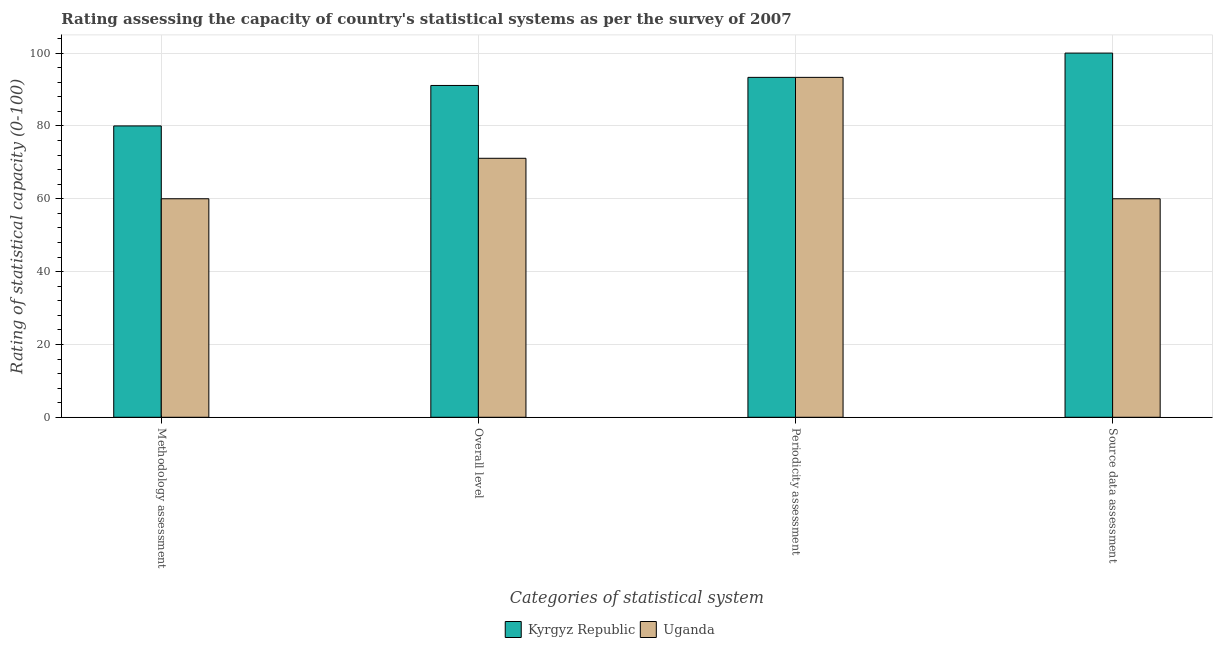How many different coloured bars are there?
Provide a succinct answer. 2. Are the number of bars per tick equal to the number of legend labels?
Give a very brief answer. Yes. What is the label of the 4th group of bars from the left?
Offer a very short reply. Source data assessment. Across all countries, what is the maximum periodicity assessment rating?
Your answer should be very brief. 93.33. Across all countries, what is the minimum source data assessment rating?
Your response must be concise. 60. In which country was the periodicity assessment rating maximum?
Give a very brief answer. Kyrgyz Republic. In which country was the overall level rating minimum?
Make the answer very short. Uganda. What is the total methodology assessment rating in the graph?
Provide a short and direct response. 140. What is the difference between the source data assessment rating in Uganda and that in Kyrgyz Republic?
Provide a short and direct response. -40. What is the difference between the methodology assessment rating in Kyrgyz Republic and the overall level rating in Uganda?
Keep it short and to the point. 8.89. What is the average overall level rating per country?
Provide a succinct answer. 81.11. What is the difference between the periodicity assessment rating and methodology assessment rating in Uganda?
Give a very brief answer. 33.33. In how many countries, is the source data assessment rating greater than 36 ?
Ensure brevity in your answer.  2. What is the ratio of the overall level rating in Uganda to that in Kyrgyz Republic?
Give a very brief answer. 0.78. What is the difference between the highest and the second highest periodicity assessment rating?
Keep it short and to the point. 0. In how many countries, is the source data assessment rating greater than the average source data assessment rating taken over all countries?
Provide a succinct answer. 1. Is it the case that in every country, the sum of the source data assessment rating and methodology assessment rating is greater than the sum of periodicity assessment rating and overall level rating?
Your response must be concise. No. What does the 2nd bar from the left in Source data assessment represents?
Keep it short and to the point. Uganda. What does the 1st bar from the right in Source data assessment represents?
Provide a short and direct response. Uganda. How many bars are there?
Ensure brevity in your answer.  8. How many countries are there in the graph?
Provide a succinct answer. 2. What is the difference between two consecutive major ticks on the Y-axis?
Offer a very short reply. 20. Does the graph contain any zero values?
Provide a succinct answer. No. Where does the legend appear in the graph?
Make the answer very short. Bottom center. How are the legend labels stacked?
Your answer should be compact. Horizontal. What is the title of the graph?
Your response must be concise. Rating assessing the capacity of country's statistical systems as per the survey of 2007 . What is the label or title of the X-axis?
Your response must be concise. Categories of statistical system. What is the label or title of the Y-axis?
Keep it short and to the point. Rating of statistical capacity (0-100). What is the Rating of statistical capacity (0-100) of Kyrgyz Republic in Methodology assessment?
Your response must be concise. 80. What is the Rating of statistical capacity (0-100) of Uganda in Methodology assessment?
Your answer should be very brief. 60. What is the Rating of statistical capacity (0-100) of Kyrgyz Republic in Overall level?
Provide a short and direct response. 91.11. What is the Rating of statistical capacity (0-100) in Uganda in Overall level?
Your answer should be very brief. 71.11. What is the Rating of statistical capacity (0-100) in Kyrgyz Republic in Periodicity assessment?
Give a very brief answer. 93.33. What is the Rating of statistical capacity (0-100) of Uganda in Periodicity assessment?
Your answer should be very brief. 93.33. What is the Rating of statistical capacity (0-100) in Kyrgyz Republic in Source data assessment?
Provide a succinct answer. 100. What is the Rating of statistical capacity (0-100) in Uganda in Source data assessment?
Make the answer very short. 60. Across all Categories of statistical system, what is the maximum Rating of statistical capacity (0-100) of Uganda?
Your answer should be compact. 93.33. What is the total Rating of statistical capacity (0-100) of Kyrgyz Republic in the graph?
Offer a very short reply. 364.44. What is the total Rating of statistical capacity (0-100) of Uganda in the graph?
Keep it short and to the point. 284.44. What is the difference between the Rating of statistical capacity (0-100) in Kyrgyz Republic in Methodology assessment and that in Overall level?
Your answer should be very brief. -11.11. What is the difference between the Rating of statistical capacity (0-100) of Uganda in Methodology assessment and that in Overall level?
Your answer should be very brief. -11.11. What is the difference between the Rating of statistical capacity (0-100) of Kyrgyz Republic in Methodology assessment and that in Periodicity assessment?
Provide a succinct answer. -13.33. What is the difference between the Rating of statistical capacity (0-100) of Uganda in Methodology assessment and that in Periodicity assessment?
Make the answer very short. -33.33. What is the difference between the Rating of statistical capacity (0-100) in Kyrgyz Republic in Overall level and that in Periodicity assessment?
Offer a terse response. -2.22. What is the difference between the Rating of statistical capacity (0-100) of Uganda in Overall level and that in Periodicity assessment?
Offer a very short reply. -22.22. What is the difference between the Rating of statistical capacity (0-100) in Kyrgyz Republic in Overall level and that in Source data assessment?
Ensure brevity in your answer.  -8.89. What is the difference between the Rating of statistical capacity (0-100) in Uganda in Overall level and that in Source data assessment?
Give a very brief answer. 11.11. What is the difference between the Rating of statistical capacity (0-100) in Kyrgyz Republic in Periodicity assessment and that in Source data assessment?
Offer a terse response. -6.67. What is the difference between the Rating of statistical capacity (0-100) of Uganda in Periodicity assessment and that in Source data assessment?
Keep it short and to the point. 33.33. What is the difference between the Rating of statistical capacity (0-100) in Kyrgyz Republic in Methodology assessment and the Rating of statistical capacity (0-100) in Uganda in Overall level?
Make the answer very short. 8.89. What is the difference between the Rating of statistical capacity (0-100) in Kyrgyz Republic in Methodology assessment and the Rating of statistical capacity (0-100) in Uganda in Periodicity assessment?
Make the answer very short. -13.33. What is the difference between the Rating of statistical capacity (0-100) of Kyrgyz Republic in Overall level and the Rating of statistical capacity (0-100) of Uganda in Periodicity assessment?
Your response must be concise. -2.22. What is the difference between the Rating of statistical capacity (0-100) of Kyrgyz Republic in Overall level and the Rating of statistical capacity (0-100) of Uganda in Source data assessment?
Offer a very short reply. 31.11. What is the difference between the Rating of statistical capacity (0-100) in Kyrgyz Republic in Periodicity assessment and the Rating of statistical capacity (0-100) in Uganda in Source data assessment?
Offer a terse response. 33.33. What is the average Rating of statistical capacity (0-100) in Kyrgyz Republic per Categories of statistical system?
Your response must be concise. 91.11. What is the average Rating of statistical capacity (0-100) of Uganda per Categories of statistical system?
Make the answer very short. 71.11. What is the ratio of the Rating of statistical capacity (0-100) of Kyrgyz Republic in Methodology assessment to that in Overall level?
Make the answer very short. 0.88. What is the ratio of the Rating of statistical capacity (0-100) in Uganda in Methodology assessment to that in Overall level?
Your response must be concise. 0.84. What is the ratio of the Rating of statistical capacity (0-100) in Kyrgyz Republic in Methodology assessment to that in Periodicity assessment?
Your response must be concise. 0.86. What is the ratio of the Rating of statistical capacity (0-100) in Uganda in Methodology assessment to that in Periodicity assessment?
Offer a terse response. 0.64. What is the ratio of the Rating of statistical capacity (0-100) of Kyrgyz Republic in Methodology assessment to that in Source data assessment?
Make the answer very short. 0.8. What is the ratio of the Rating of statistical capacity (0-100) of Kyrgyz Republic in Overall level to that in Periodicity assessment?
Keep it short and to the point. 0.98. What is the ratio of the Rating of statistical capacity (0-100) in Uganda in Overall level to that in Periodicity assessment?
Provide a succinct answer. 0.76. What is the ratio of the Rating of statistical capacity (0-100) in Kyrgyz Republic in Overall level to that in Source data assessment?
Your answer should be compact. 0.91. What is the ratio of the Rating of statistical capacity (0-100) in Uganda in Overall level to that in Source data assessment?
Offer a very short reply. 1.19. What is the ratio of the Rating of statistical capacity (0-100) in Uganda in Periodicity assessment to that in Source data assessment?
Provide a succinct answer. 1.56. What is the difference between the highest and the second highest Rating of statistical capacity (0-100) of Kyrgyz Republic?
Ensure brevity in your answer.  6.67. What is the difference between the highest and the second highest Rating of statistical capacity (0-100) in Uganda?
Ensure brevity in your answer.  22.22. What is the difference between the highest and the lowest Rating of statistical capacity (0-100) in Uganda?
Keep it short and to the point. 33.33. 